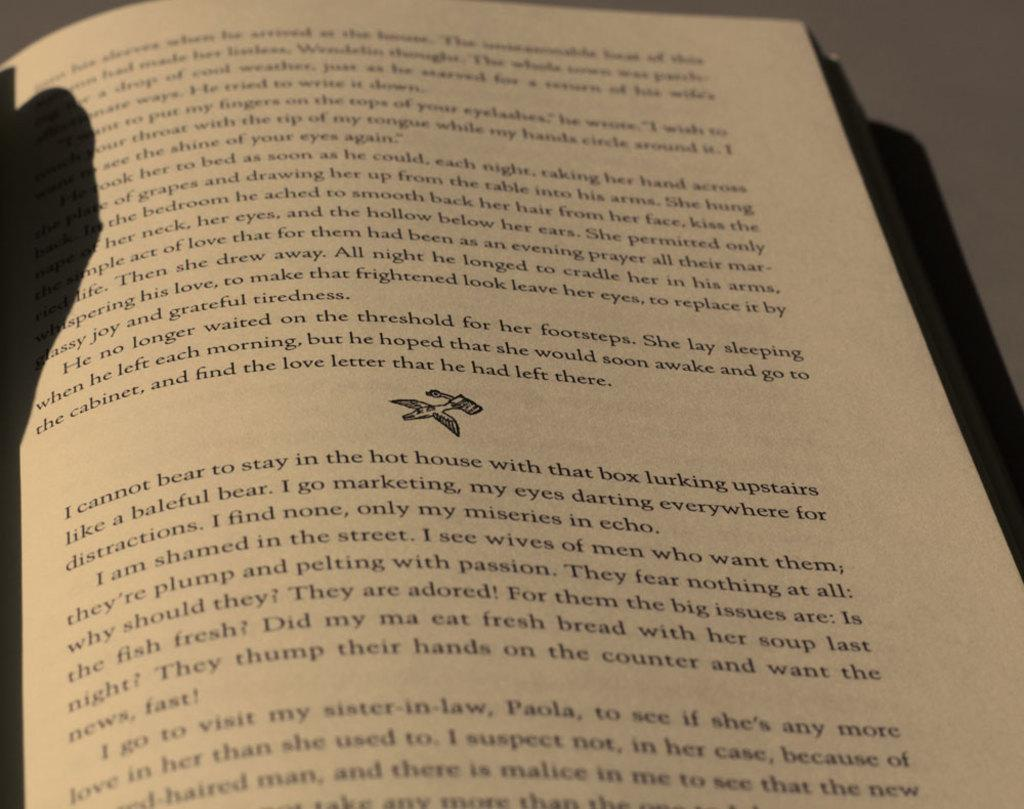Provide a one-sentence caption for the provided image. A book page is laying open on a page that has the words, "I cannot bear to stay in the hot house...", written in the second paragraph. 